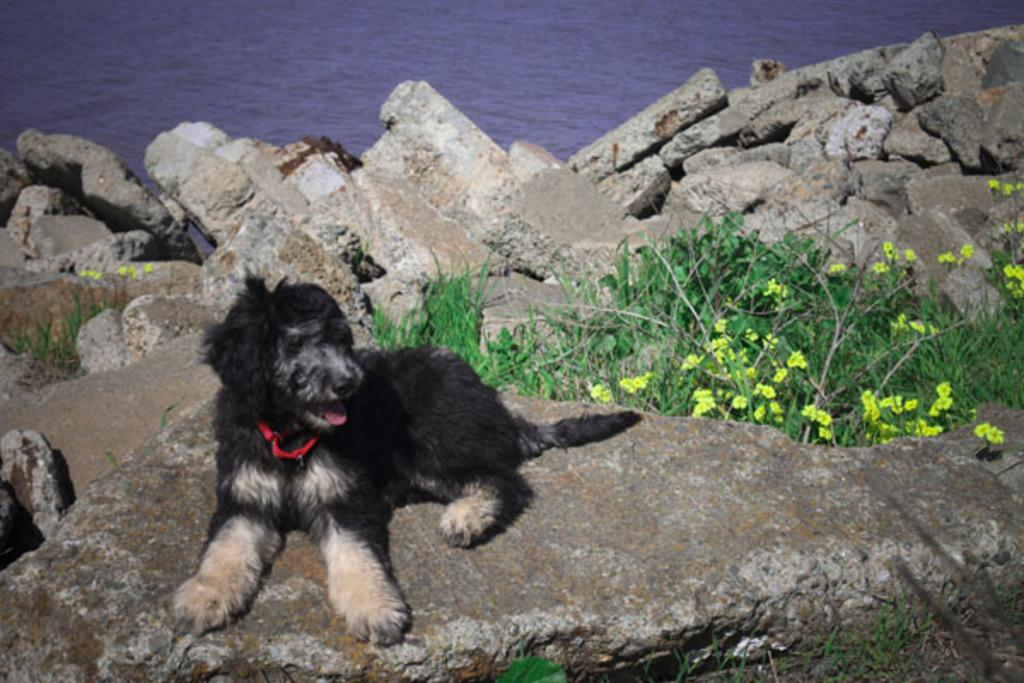What type of animal can be seen at the bottom of the image? There is a dog present at the bottom of the image. What can be found in the middle of the image? Flower plants and rocks are present in the middle of the image. What is visible in the background of the image? The surface of water is visible in the background of the image. What type of art can be seen on the dog's elbow in the image? There is no art or mention of an elbow on the dog in the image. What time of day is depicted in the image? The provided facts do not give any information about the time of day, so it cannot be determined from the image. 